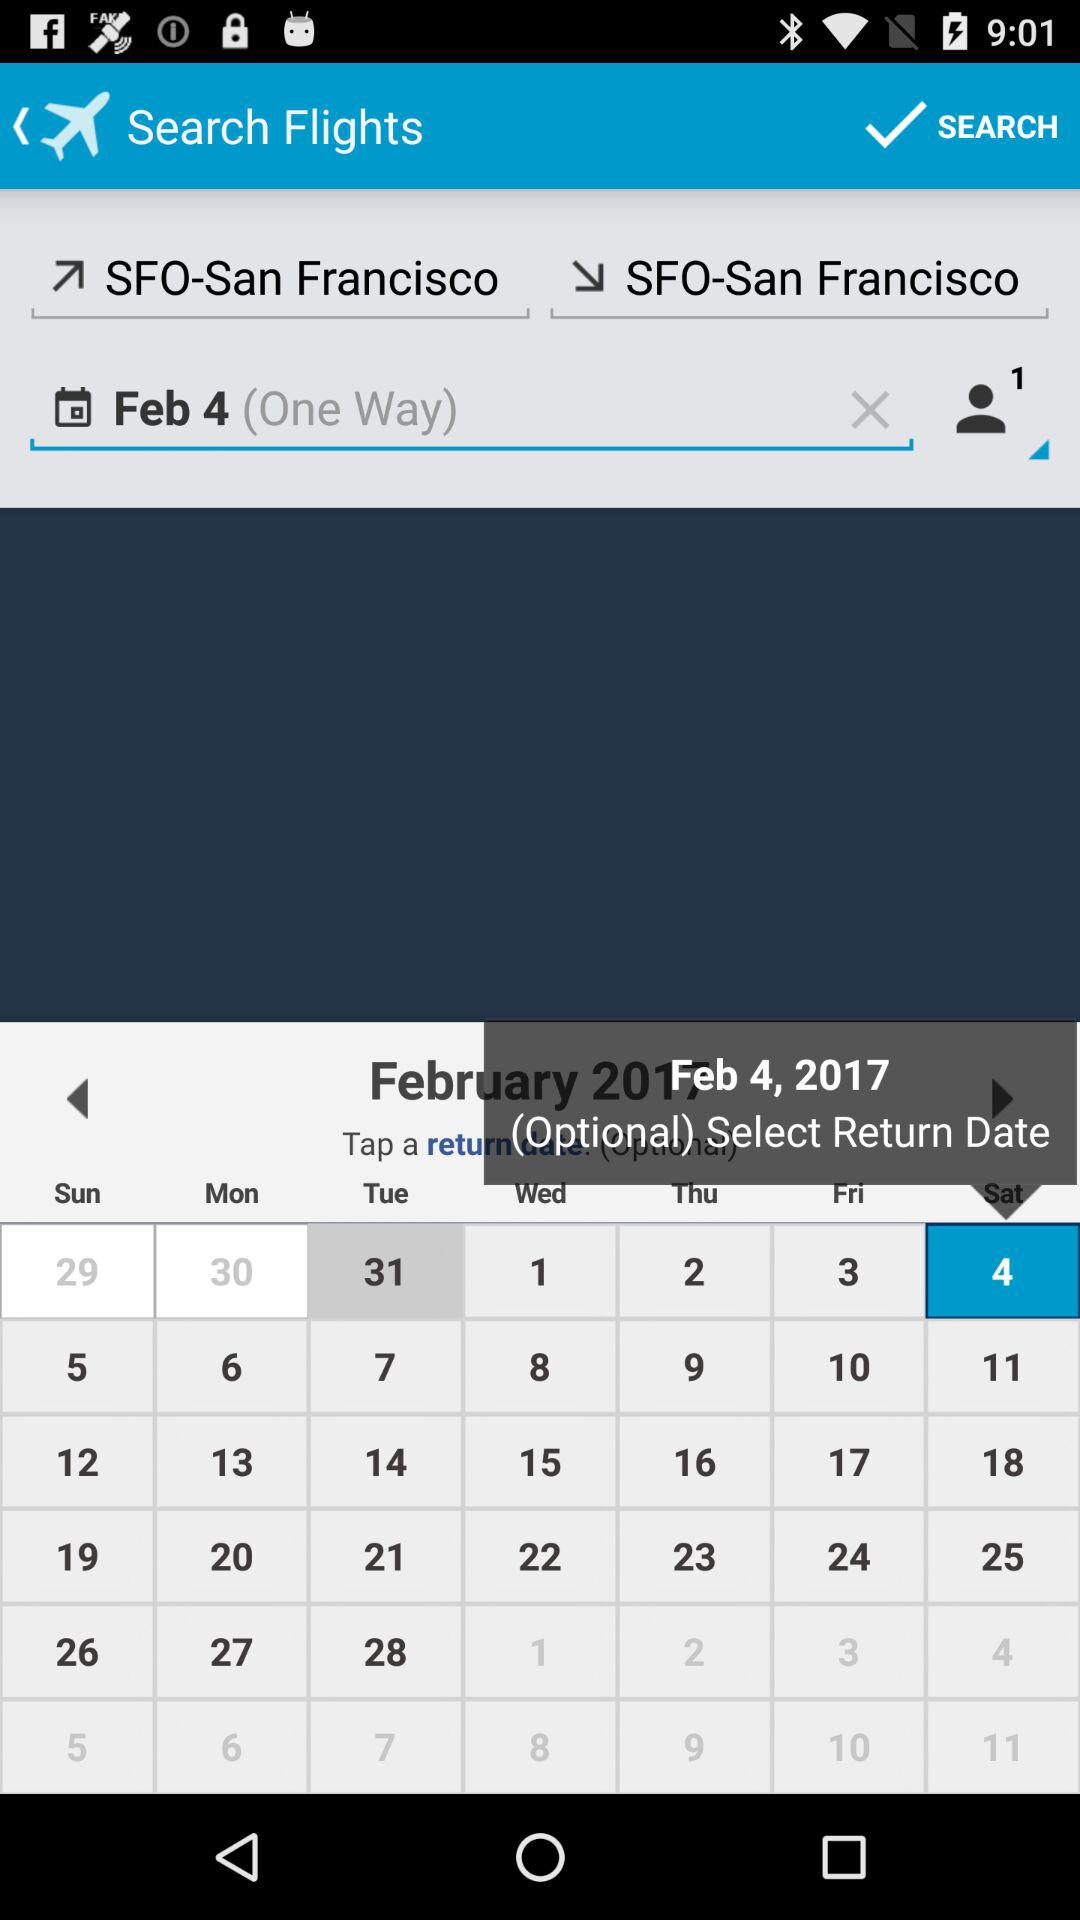What is the city name for code SFO? The name of the city is San Francisco. 